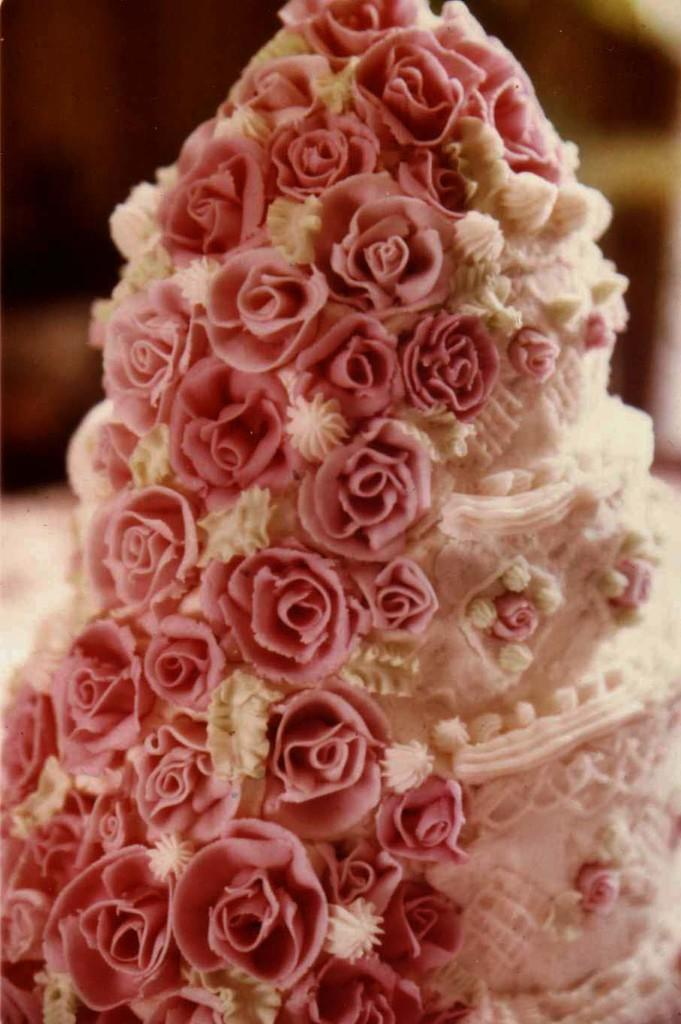What type of cake is shown in the image? There is a white color cake in the image. Are there any decorations on the cake? Yes, there are pink color flowers on the cake. Can you describe the background of the image? The background of the image is blurred. What type of pest can be seen crawling on the cake in the image? There are no pests visible on the cake in the image. Is there a ring on the cake in the image? The image does not show a ring on the cake. 